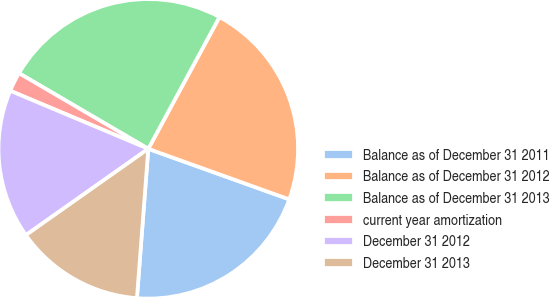Convert chart to OTSL. <chart><loc_0><loc_0><loc_500><loc_500><pie_chart><fcel>Balance as of December 31 2011<fcel>Balance as of December 31 2012<fcel>Balance as of December 31 2013<fcel>current year amortization<fcel>December 31 2012<fcel>December 31 2013<nl><fcel>20.73%<fcel>22.6%<fcel>24.46%<fcel>2.09%<fcel>16.11%<fcel>14.02%<nl></chart> 